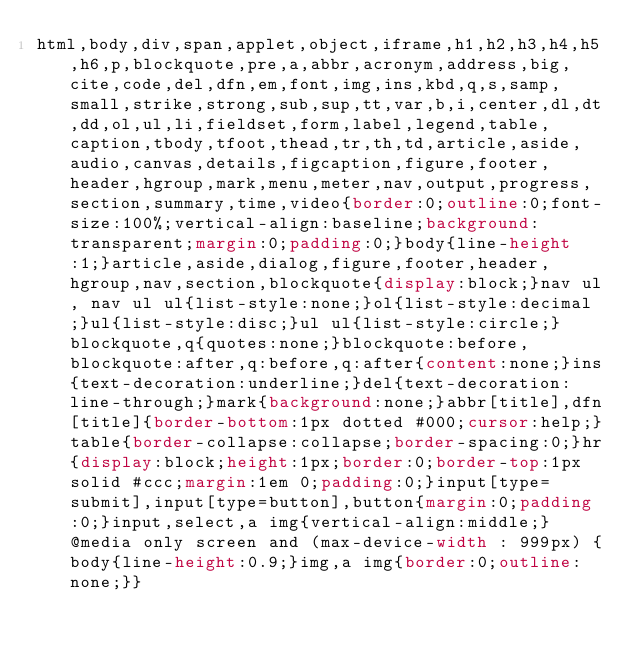<code> <loc_0><loc_0><loc_500><loc_500><_CSS_>html,body,div,span,applet,object,iframe,h1,h2,h3,h4,h5,h6,p,blockquote,pre,a,abbr,acronym,address,big,cite,code,del,dfn,em,font,img,ins,kbd,q,s,samp,small,strike,strong,sub,sup,tt,var,b,i,center,dl,dt,dd,ol,ul,li,fieldset,form,label,legend,table,caption,tbody,tfoot,thead,tr,th,td,article,aside,audio,canvas,details,figcaption,figure,footer,header,hgroup,mark,menu,meter,nav,output,progress,section,summary,time,video{border:0;outline:0;font-size:100%;vertical-align:baseline;background:transparent;margin:0;padding:0;}body{line-height:1;}article,aside,dialog,figure,footer,header,hgroup,nav,section,blockquote{display:block;}nav ul, nav ul ul{list-style:none;}ol{list-style:decimal;}ul{list-style:disc;}ul ul{list-style:circle;}blockquote,q{quotes:none;}blockquote:before,blockquote:after,q:before,q:after{content:none;}ins{text-decoration:underline;}del{text-decoration:line-through;}mark{background:none;}abbr[title],dfn[title]{border-bottom:1px dotted #000;cursor:help;}table{border-collapse:collapse;border-spacing:0;}hr{display:block;height:1px;border:0;border-top:1px solid #ccc;margin:1em 0;padding:0;}input[type=submit],input[type=button],button{margin:0;padding:0;}input,select,a img{vertical-align:middle;}@media only screen and (max-device-width : 999px) {body{line-height:0.9;}img,a img{border:0;outline:none;}}</code> 